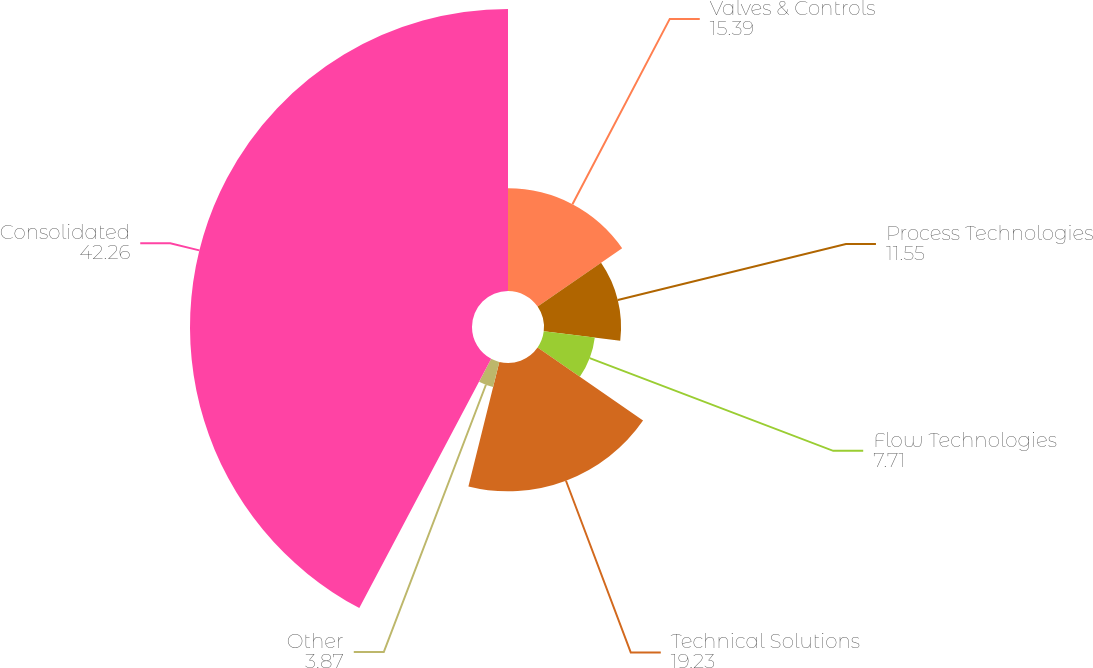Convert chart to OTSL. <chart><loc_0><loc_0><loc_500><loc_500><pie_chart><fcel>Valves & Controls<fcel>Process Technologies<fcel>Flow Technologies<fcel>Technical Solutions<fcel>Other<fcel>Consolidated<nl><fcel>15.39%<fcel>11.55%<fcel>7.71%<fcel>19.23%<fcel>3.87%<fcel>42.26%<nl></chart> 